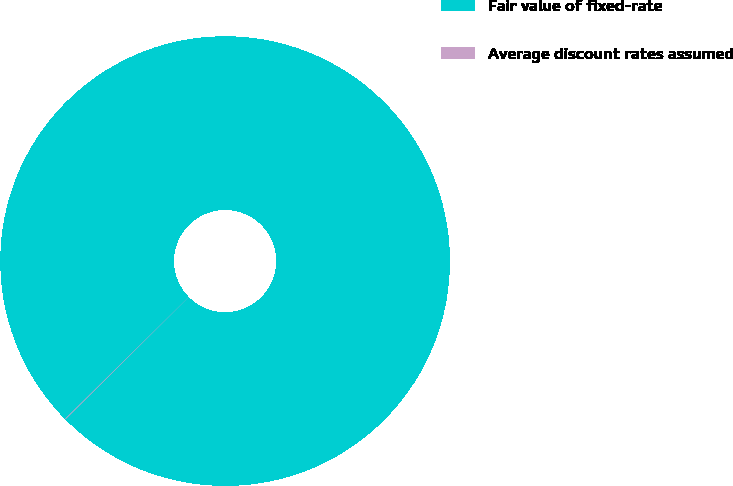Convert chart to OTSL. <chart><loc_0><loc_0><loc_500><loc_500><pie_chart><fcel>Fair value of fixed-rate<fcel>Average discount rates assumed<nl><fcel>99.95%<fcel>0.05%<nl></chart> 